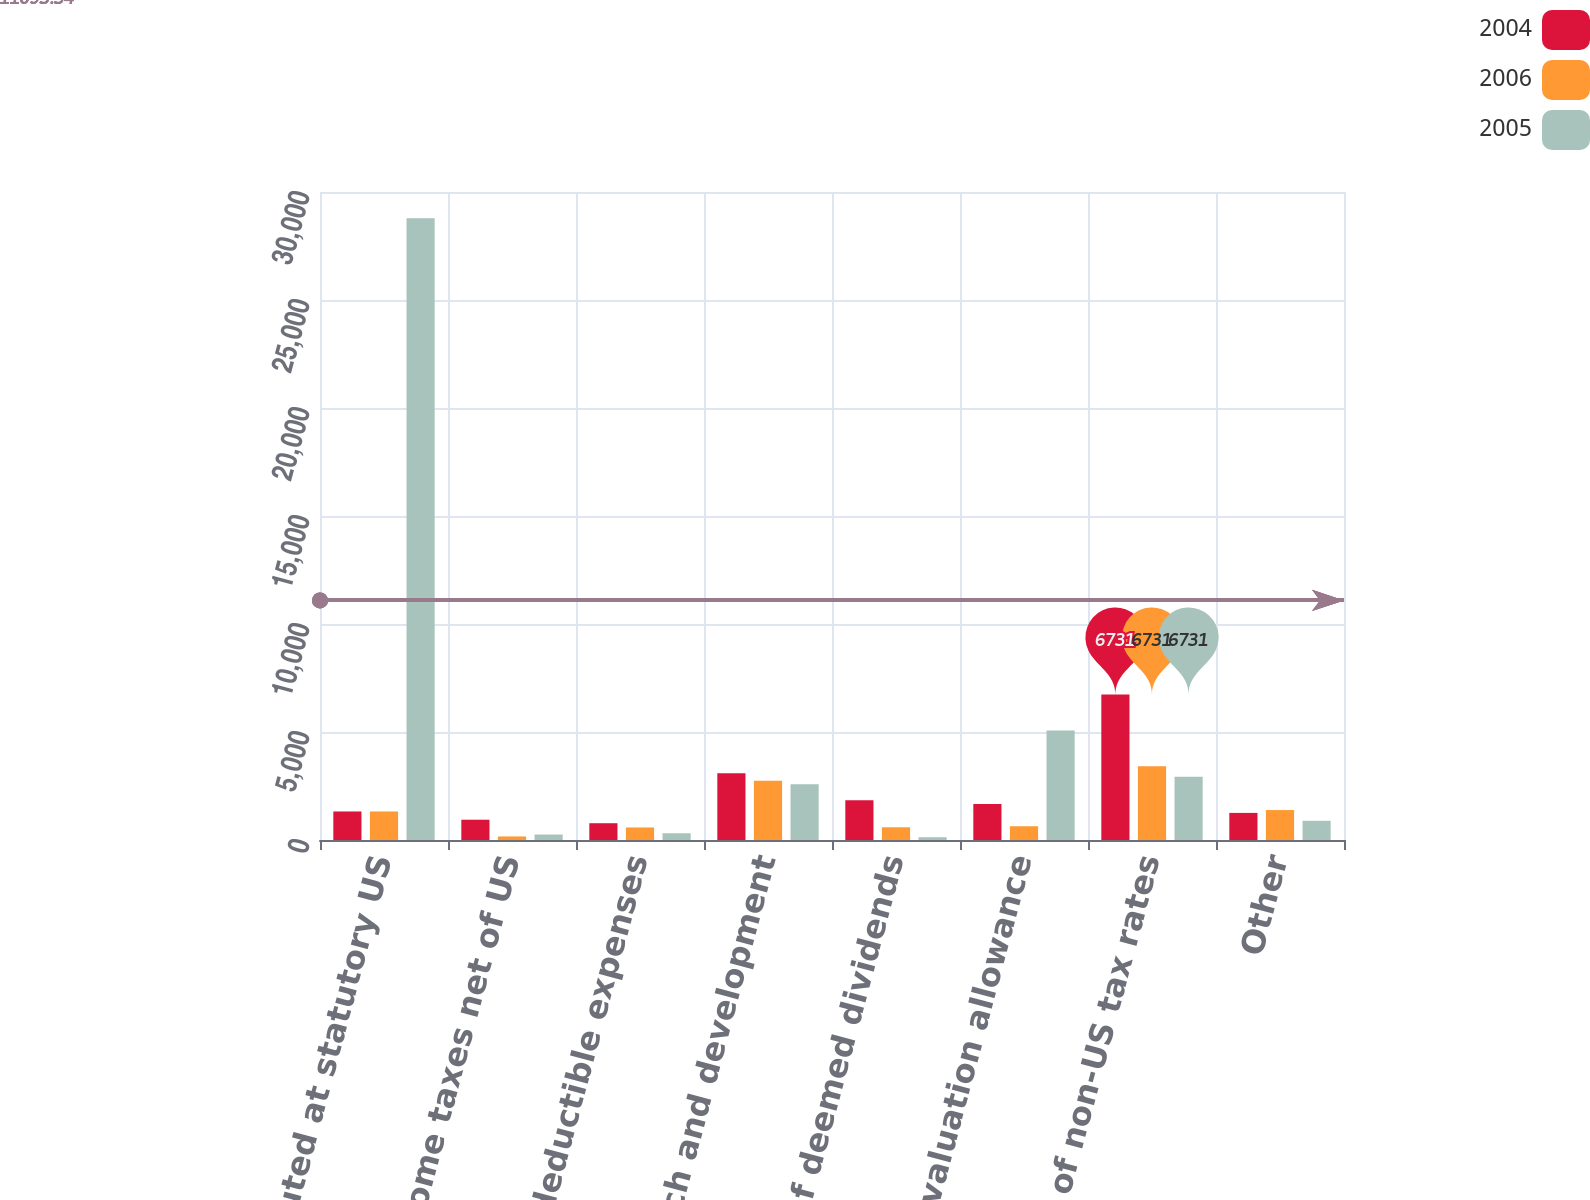Convert chart. <chart><loc_0><loc_0><loc_500><loc_500><stacked_bar_chart><ecel><fcel>Taxes computed at statutory US<fcel>State income taxes net of US<fcel>Non-deductible expenses<fcel>Research and development<fcel>Tax effect of deemed dividends<fcel>Change in valuation allowance<fcel>Effect of non-US tax rates<fcel>Other<nl><fcel>2004<fcel>1321<fcel>939<fcel>777<fcel>3085<fcel>1846<fcel>1665<fcel>6731<fcel>1255<nl><fcel>2006<fcel>1321<fcel>165<fcel>580<fcel>2743<fcel>590<fcel>637<fcel>3419<fcel>1387<nl><fcel>2005<fcel>28787<fcel>254<fcel>312<fcel>2582<fcel>129<fcel>5074<fcel>2930<fcel>888<nl></chart> 